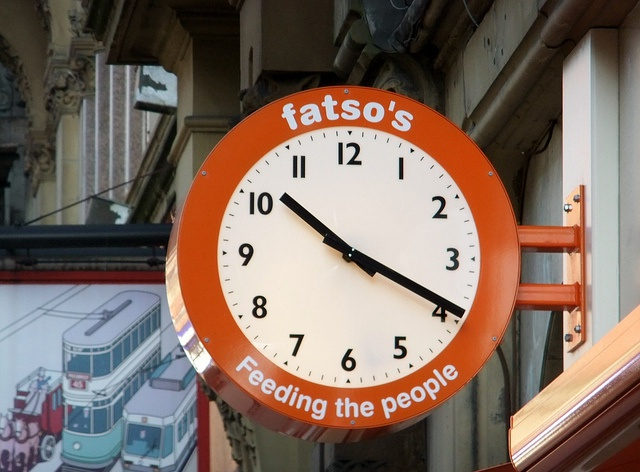Describe the objects in this image and their specific colors. I can see a clock in black, lightgray, and tan tones in this image. 